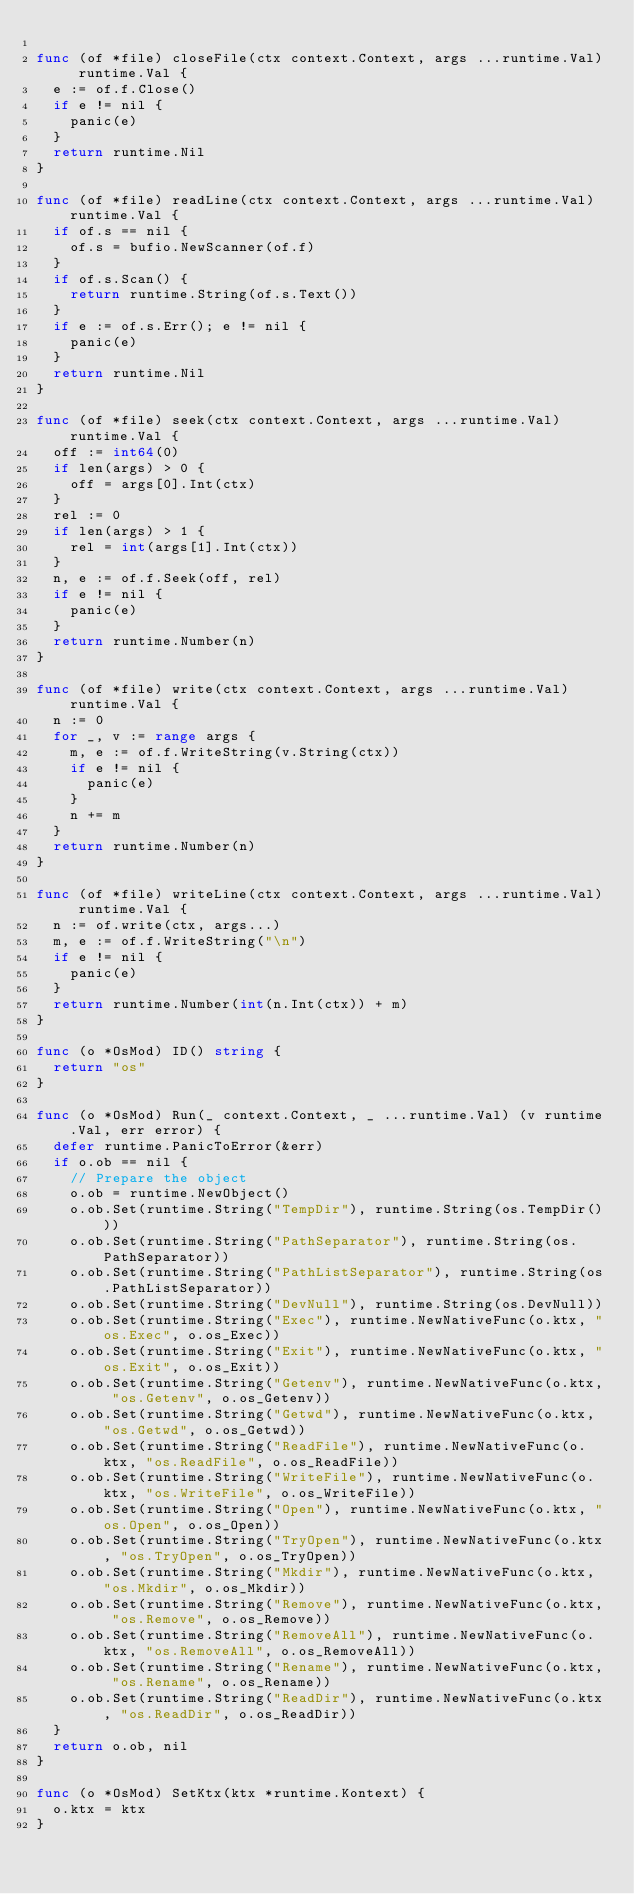Convert code to text. <code><loc_0><loc_0><loc_500><loc_500><_Go_>
func (of *file) closeFile(ctx context.Context, args ...runtime.Val) runtime.Val {
	e := of.f.Close()
	if e != nil {
		panic(e)
	}
	return runtime.Nil
}

func (of *file) readLine(ctx context.Context, args ...runtime.Val) runtime.Val {
	if of.s == nil {
		of.s = bufio.NewScanner(of.f)
	}
	if of.s.Scan() {
		return runtime.String(of.s.Text())
	}
	if e := of.s.Err(); e != nil {
		panic(e)
	}
	return runtime.Nil
}

func (of *file) seek(ctx context.Context, args ...runtime.Val) runtime.Val {
	off := int64(0)
	if len(args) > 0 {
		off = args[0].Int(ctx)
	}
	rel := 0
	if len(args) > 1 {
		rel = int(args[1].Int(ctx))
	}
	n, e := of.f.Seek(off, rel)
	if e != nil {
		panic(e)
	}
	return runtime.Number(n)
}

func (of *file) write(ctx context.Context, args ...runtime.Val) runtime.Val {
	n := 0
	for _, v := range args {
		m, e := of.f.WriteString(v.String(ctx))
		if e != nil {
			panic(e)
		}
		n += m
	}
	return runtime.Number(n)
}

func (of *file) writeLine(ctx context.Context, args ...runtime.Val) runtime.Val {
	n := of.write(ctx, args...)
	m, e := of.f.WriteString("\n")
	if e != nil {
		panic(e)
	}
	return runtime.Number(int(n.Int(ctx)) + m)
}

func (o *OsMod) ID() string {
	return "os"
}

func (o *OsMod) Run(_ context.Context, _ ...runtime.Val) (v runtime.Val, err error) {
	defer runtime.PanicToError(&err)
	if o.ob == nil {
		// Prepare the object
		o.ob = runtime.NewObject()
		o.ob.Set(runtime.String("TempDir"), runtime.String(os.TempDir()))
		o.ob.Set(runtime.String("PathSeparator"), runtime.String(os.PathSeparator))
		o.ob.Set(runtime.String("PathListSeparator"), runtime.String(os.PathListSeparator))
		o.ob.Set(runtime.String("DevNull"), runtime.String(os.DevNull))
		o.ob.Set(runtime.String("Exec"), runtime.NewNativeFunc(o.ktx, "os.Exec", o.os_Exec))
		o.ob.Set(runtime.String("Exit"), runtime.NewNativeFunc(o.ktx, "os.Exit", o.os_Exit))
		o.ob.Set(runtime.String("Getenv"), runtime.NewNativeFunc(o.ktx, "os.Getenv", o.os_Getenv))
		o.ob.Set(runtime.String("Getwd"), runtime.NewNativeFunc(o.ktx, "os.Getwd", o.os_Getwd))
		o.ob.Set(runtime.String("ReadFile"), runtime.NewNativeFunc(o.ktx, "os.ReadFile", o.os_ReadFile))
		o.ob.Set(runtime.String("WriteFile"), runtime.NewNativeFunc(o.ktx, "os.WriteFile", o.os_WriteFile))
		o.ob.Set(runtime.String("Open"), runtime.NewNativeFunc(o.ktx, "os.Open", o.os_Open))
		o.ob.Set(runtime.String("TryOpen"), runtime.NewNativeFunc(o.ktx, "os.TryOpen", o.os_TryOpen))
		o.ob.Set(runtime.String("Mkdir"), runtime.NewNativeFunc(o.ktx, "os.Mkdir", o.os_Mkdir))
		o.ob.Set(runtime.String("Remove"), runtime.NewNativeFunc(o.ktx, "os.Remove", o.os_Remove))
		o.ob.Set(runtime.String("RemoveAll"), runtime.NewNativeFunc(o.ktx, "os.RemoveAll", o.os_RemoveAll))
		o.ob.Set(runtime.String("Rename"), runtime.NewNativeFunc(o.ktx, "os.Rename", o.os_Rename))
		o.ob.Set(runtime.String("ReadDir"), runtime.NewNativeFunc(o.ktx, "os.ReadDir", o.os_ReadDir))
	}
	return o.ob, nil
}

func (o *OsMod) SetKtx(ktx *runtime.Kontext) {
	o.ktx = ktx
}
</code> 